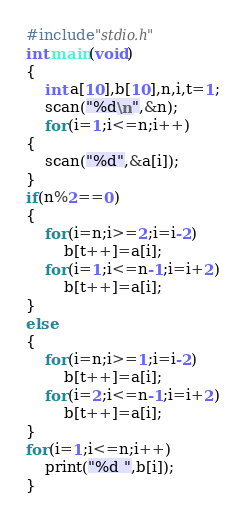<code> <loc_0><loc_0><loc_500><loc_500><_C_>#include"stdio.h"
int main(void)
{
    int a[10],b[10],n,i,t=1;
    scan("%d\n",&n);
    for(i=1;i<=n;i++)
{
    scan("%d",&a[i]);
}
if(n%2==0)
{
    for(i=n;i>=2;i=i-2)
        b[t++]=a[i];
    for(i=1;i<=n-1;i=i+2)
        b[t++]=a[i];
}
else
{
    for(i=n;i>=1;i=i-2)
        b[t++]=a[i];
    for(i=2;i<=n-1;i=i+2)
        b[t++]=a[i];
}
for(i=1;i<=n;i++)
    print("%d ",b[i]);
}
</code> 